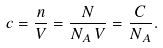<formula> <loc_0><loc_0><loc_500><loc_500>c = { \frac { n } { V } } = { \frac { N } { N _ { A } \, V } } = { \frac { C } { N _ { A } } } .</formula> 